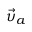Convert formula to latex. <formula><loc_0><loc_0><loc_500><loc_500>{ \vec { \upsilon } } _ { a }</formula> 